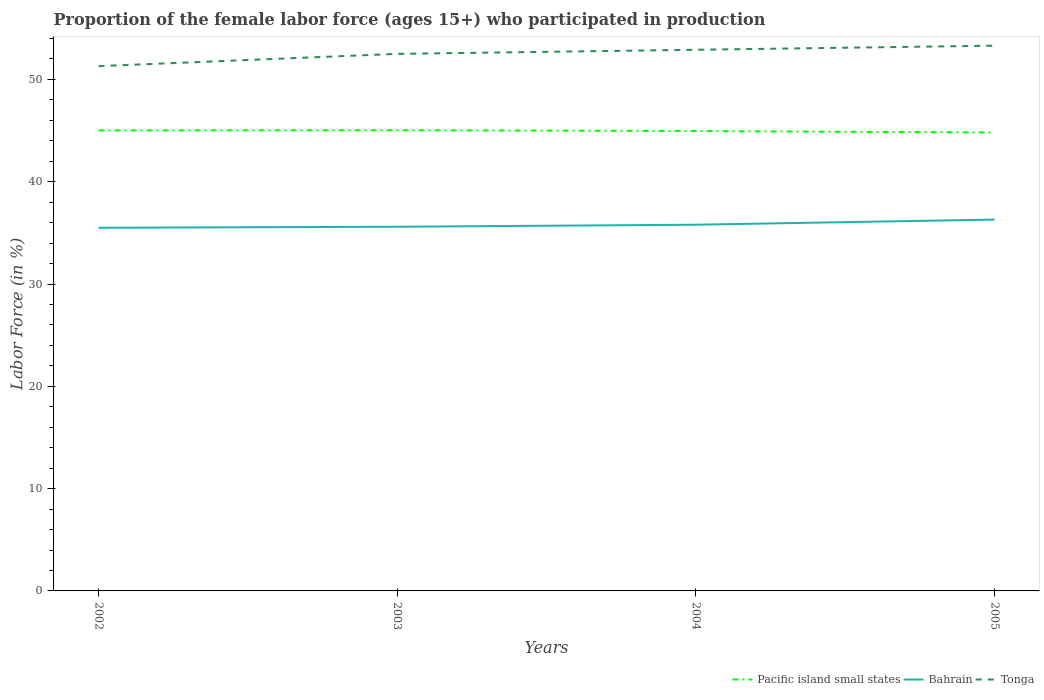How many different coloured lines are there?
Make the answer very short. 3. Does the line corresponding to Tonga intersect with the line corresponding to Bahrain?
Keep it short and to the point. No. Is the number of lines equal to the number of legend labels?
Make the answer very short. Yes. Across all years, what is the maximum proportion of the female labor force who participated in production in Tonga?
Keep it short and to the point. 51.3. In which year was the proportion of the female labor force who participated in production in Bahrain maximum?
Offer a very short reply. 2002. What is the total proportion of the female labor force who participated in production in Bahrain in the graph?
Provide a succinct answer. -0.3. What is the difference between the highest and the second highest proportion of the female labor force who participated in production in Pacific island small states?
Your answer should be very brief. 0.22. How many years are there in the graph?
Provide a succinct answer. 4. What is the difference between two consecutive major ticks on the Y-axis?
Provide a short and direct response. 10. How many legend labels are there?
Give a very brief answer. 3. What is the title of the graph?
Ensure brevity in your answer.  Proportion of the female labor force (ages 15+) who participated in production. What is the Labor Force (in %) of Pacific island small states in 2002?
Provide a succinct answer. 45.02. What is the Labor Force (in %) in Bahrain in 2002?
Offer a very short reply. 35.5. What is the Labor Force (in %) of Tonga in 2002?
Provide a short and direct response. 51.3. What is the Labor Force (in %) in Pacific island small states in 2003?
Offer a terse response. 45.04. What is the Labor Force (in %) of Bahrain in 2003?
Provide a succinct answer. 35.6. What is the Labor Force (in %) of Tonga in 2003?
Provide a short and direct response. 52.5. What is the Labor Force (in %) in Pacific island small states in 2004?
Your answer should be very brief. 44.95. What is the Labor Force (in %) in Bahrain in 2004?
Keep it short and to the point. 35.8. What is the Labor Force (in %) of Tonga in 2004?
Your answer should be very brief. 52.9. What is the Labor Force (in %) of Pacific island small states in 2005?
Offer a very short reply. 44.81. What is the Labor Force (in %) of Bahrain in 2005?
Make the answer very short. 36.3. What is the Labor Force (in %) of Tonga in 2005?
Provide a short and direct response. 53.3. Across all years, what is the maximum Labor Force (in %) in Pacific island small states?
Offer a very short reply. 45.04. Across all years, what is the maximum Labor Force (in %) in Bahrain?
Ensure brevity in your answer.  36.3. Across all years, what is the maximum Labor Force (in %) in Tonga?
Ensure brevity in your answer.  53.3. Across all years, what is the minimum Labor Force (in %) in Pacific island small states?
Your response must be concise. 44.81. Across all years, what is the minimum Labor Force (in %) of Bahrain?
Keep it short and to the point. 35.5. Across all years, what is the minimum Labor Force (in %) of Tonga?
Your response must be concise. 51.3. What is the total Labor Force (in %) of Pacific island small states in the graph?
Provide a short and direct response. 179.82. What is the total Labor Force (in %) in Bahrain in the graph?
Provide a short and direct response. 143.2. What is the total Labor Force (in %) of Tonga in the graph?
Ensure brevity in your answer.  210. What is the difference between the Labor Force (in %) in Pacific island small states in 2002 and that in 2003?
Make the answer very short. -0.02. What is the difference between the Labor Force (in %) in Tonga in 2002 and that in 2003?
Provide a succinct answer. -1.2. What is the difference between the Labor Force (in %) of Pacific island small states in 2002 and that in 2004?
Make the answer very short. 0.06. What is the difference between the Labor Force (in %) of Tonga in 2002 and that in 2004?
Your answer should be very brief. -1.6. What is the difference between the Labor Force (in %) in Pacific island small states in 2002 and that in 2005?
Provide a short and direct response. 0.2. What is the difference between the Labor Force (in %) of Pacific island small states in 2003 and that in 2004?
Offer a terse response. 0.08. What is the difference between the Labor Force (in %) in Tonga in 2003 and that in 2004?
Your response must be concise. -0.4. What is the difference between the Labor Force (in %) in Pacific island small states in 2003 and that in 2005?
Your answer should be very brief. 0.22. What is the difference between the Labor Force (in %) in Bahrain in 2003 and that in 2005?
Your answer should be compact. -0.7. What is the difference between the Labor Force (in %) of Tonga in 2003 and that in 2005?
Ensure brevity in your answer.  -0.8. What is the difference between the Labor Force (in %) of Pacific island small states in 2004 and that in 2005?
Your response must be concise. 0.14. What is the difference between the Labor Force (in %) of Pacific island small states in 2002 and the Labor Force (in %) of Bahrain in 2003?
Give a very brief answer. 9.42. What is the difference between the Labor Force (in %) of Pacific island small states in 2002 and the Labor Force (in %) of Tonga in 2003?
Make the answer very short. -7.48. What is the difference between the Labor Force (in %) in Bahrain in 2002 and the Labor Force (in %) in Tonga in 2003?
Offer a terse response. -17. What is the difference between the Labor Force (in %) of Pacific island small states in 2002 and the Labor Force (in %) of Bahrain in 2004?
Your answer should be very brief. 9.22. What is the difference between the Labor Force (in %) in Pacific island small states in 2002 and the Labor Force (in %) in Tonga in 2004?
Make the answer very short. -7.88. What is the difference between the Labor Force (in %) in Bahrain in 2002 and the Labor Force (in %) in Tonga in 2004?
Keep it short and to the point. -17.4. What is the difference between the Labor Force (in %) of Pacific island small states in 2002 and the Labor Force (in %) of Bahrain in 2005?
Your answer should be very brief. 8.72. What is the difference between the Labor Force (in %) of Pacific island small states in 2002 and the Labor Force (in %) of Tonga in 2005?
Ensure brevity in your answer.  -8.28. What is the difference between the Labor Force (in %) of Bahrain in 2002 and the Labor Force (in %) of Tonga in 2005?
Ensure brevity in your answer.  -17.8. What is the difference between the Labor Force (in %) of Pacific island small states in 2003 and the Labor Force (in %) of Bahrain in 2004?
Give a very brief answer. 9.24. What is the difference between the Labor Force (in %) of Pacific island small states in 2003 and the Labor Force (in %) of Tonga in 2004?
Offer a very short reply. -7.86. What is the difference between the Labor Force (in %) in Bahrain in 2003 and the Labor Force (in %) in Tonga in 2004?
Your answer should be compact. -17.3. What is the difference between the Labor Force (in %) of Pacific island small states in 2003 and the Labor Force (in %) of Bahrain in 2005?
Provide a short and direct response. 8.74. What is the difference between the Labor Force (in %) of Pacific island small states in 2003 and the Labor Force (in %) of Tonga in 2005?
Provide a short and direct response. -8.26. What is the difference between the Labor Force (in %) in Bahrain in 2003 and the Labor Force (in %) in Tonga in 2005?
Your answer should be compact. -17.7. What is the difference between the Labor Force (in %) of Pacific island small states in 2004 and the Labor Force (in %) of Bahrain in 2005?
Provide a succinct answer. 8.65. What is the difference between the Labor Force (in %) of Pacific island small states in 2004 and the Labor Force (in %) of Tonga in 2005?
Provide a short and direct response. -8.35. What is the difference between the Labor Force (in %) of Bahrain in 2004 and the Labor Force (in %) of Tonga in 2005?
Your answer should be compact. -17.5. What is the average Labor Force (in %) of Pacific island small states per year?
Your answer should be very brief. 44.96. What is the average Labor Force (in %) of Bahrain per year?
Provide a short and direct response. 35.8. What is the average Labor Force (in %) in Tonga per year?
Give a very brief answer. 52.5. In the year 2002, what is the difference between the Labor Force (in %) of Pacific island small states and Labor Force (in %) of Bahrain?
Provide a succinct answer. 9.52. In the year 2002, what is the difference between the Labor Force (in %) of Pacific island small states and Labor Force (in %) of Tonga?
Offer a terse response. -6.28. In the year 2002, what is the difference between the Labor Force (in %) of Bahrain and Labor Force (in %) of Tonga?
Offer a very short reply. -15.8. In the year 2003, what is the difference between the Labor Force (in %) in Pacific island small states and Labor Force (in %) in Bahrain?
Provide a short and direct response. 9.44. In the year 2003, what is the difference between the Labor Force (in %) of Pacific island small states and Labor Force (in %) of Tonga?
Give a very brief answer. -7.46. In the year 2003, what is the difference between the Labor Force (in %) in Bahrain and Labor Force (in %) in Tonga?
Offer a terse response. -16.9. In the year 2004, what is the difference between the Labor Force (in %) of Pacific island small states and Labor Force (in %) of Bahrain?
Your answer should be compact. 9.15. In the year 2004, what is the difference between the Labor Force (in %) in Pacific island small states and Labor Force (in %) in Tonga?
Provide a short and direct response. -7.95. In the year 2004, what is the difference between the Labor Force (in %) of Bahrain and Labor Force (in %) of Tonga?
Offer a very short reply. -17.1. In the year 2005, what is the difference between the Labor Force (in %) in Pacific island small states and Labor Force (in %) in Bahrain?
Your response must be concise. 8.51. In the year 2005, what is the difference between the Labor Force (in %) in Pacific island small states and Labor Force (in %) in Tonga?
Your answer should be very brief. -8.49. What is the ratio of the Labor Force (in %) of Pacific island small states in 2002 to that in 2003?
Offer a terse response. 1. What is the ratio of the Labor Force (in %) in Tonga in 2002 to that in 2003?
Ensure brevity in your answer.  0.98. What is the ratio of the Labor Force (in %) of Tonga in 2002 to that in 2004?
Your response must be concise. 0.97. What is the ratio of the Labor Force (in %) of Pacific island small states in 2002 to that in 2005?
Provide a succinct answer. 1. What is the ratio of the Labor Force (in %) of Tonga in 2002 to that in 2005?
Ensure brevity in your answer.  0.96. What is the ratio of the Labor Force (in %) of Tonga in 2003 to that in 2004?
Ensure brevity in your answer.  0.99. What is the ratio of the Labor Force (in %) in Bahrain in 2003 to that in 2005?
Ensure brevity in your answer.  0.98. What is the ratio of the Labor Force (in %) of Pacific island small states in 2004 to that in 2005?
Make the answer very short. 1. What is the ratio of the Labor Force (in %) of Bahrain in 2004 to that in 2005?
Your answer should be very brief. 0.99. What is the difference between the highest and the second highest Labor Force (in %) in Pacific island small states?
Give a very brief answer. 0.02. What is the difference between the highest and the second highest Labor Force (in %) in Tonga?
Keep it short and to the point. 0.4. What is the difference between the highest and the lowest Labor Force (in %) of Pacific island small states?
Keep it short and to the point. 0.22. What is the difference between the highest and the lowest Labor Force (in %) of Bahrain?
Give a very brief answer. 0.8. 